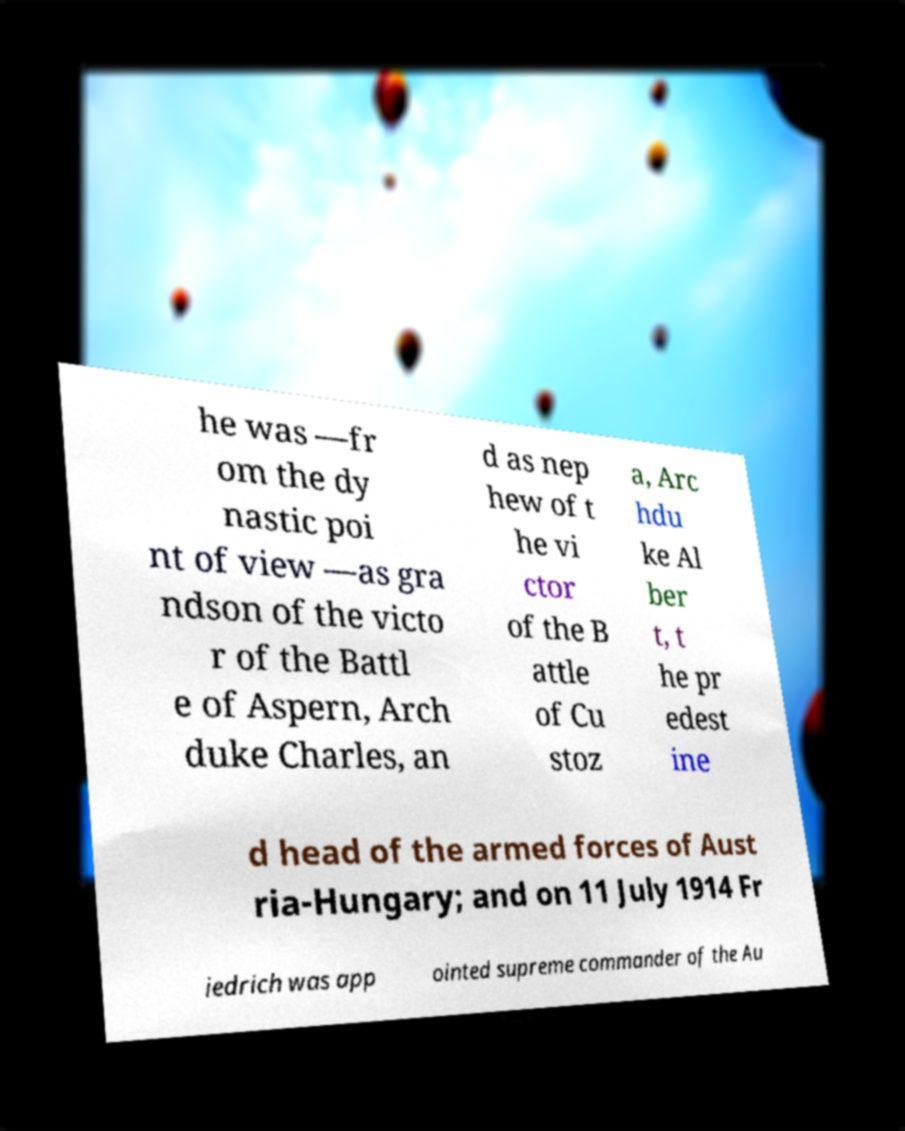Could you extract and type out the text from this image? he was —fr om the dy nastic poi nt of view —as gra ndson of the victo r of the Battl e of Aspern, Arch duke Charles, an d as nep hew of t he vi ctor of the B attle of Cu stoz a, Arc hdu ke Al ber t, t he pr edest ine d head of the armed forces of Aust ria-Hungary; and on 11 July 1914 Fr iedrich was app ointed supreme commander of the Au 